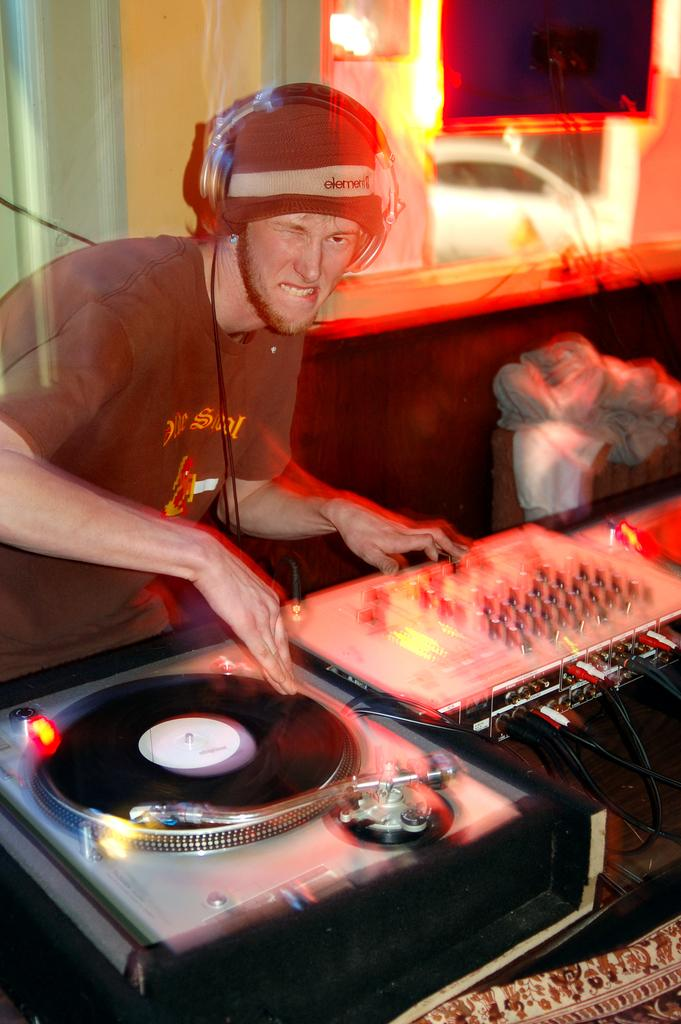Who is present in the image? There is a man in the image. What is the man wearing? The man is wearing a headphone. What is in front of the man? There is a musical instrument in front of the man. Can you describe the background of the image? There may be a wall in the background of the image, and there is a light focus visible on the wall. What type of flower is growing on the wall in the image? There is no flower visible on the wall in the image. Can you see any stars in the image? There are no stars visible in the image. 